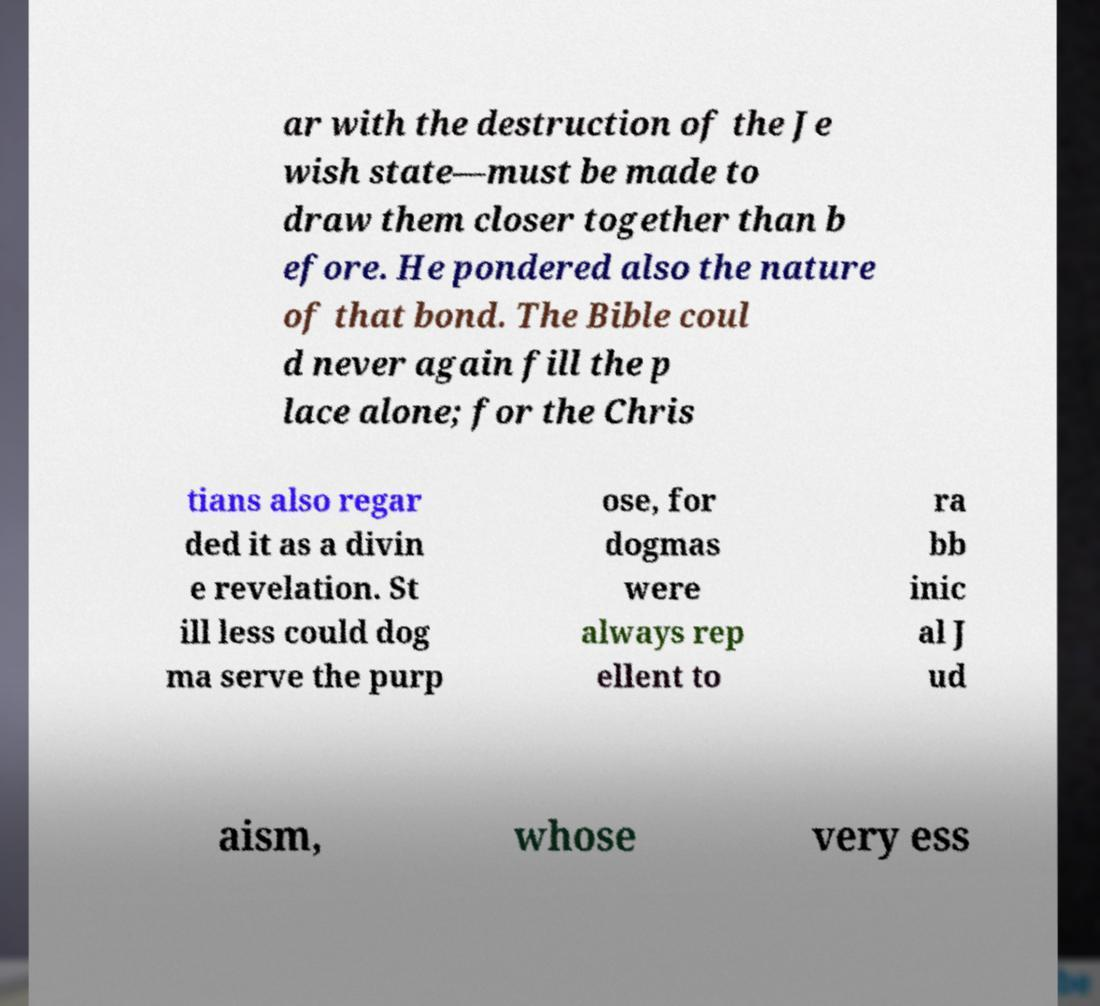What messages or text are displayed in this image? I need them in a readable, typed format. ar with the destruction of the Je wish state—must be made to draw them closer together than b efore. He pondered also the nature of that bond. The Bible coul d never again fill the p lace alone; for the Chris tians also regar ded it as a divin e revelation. St ill less could dog ma serve the purp ose, for dogmas were always rep ellent to ra bb inic al J ud aism, whose very ess 